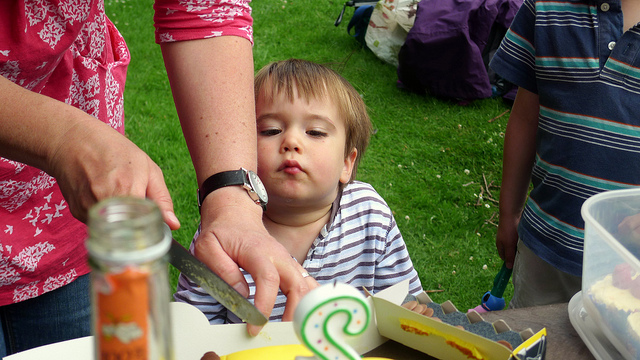What type of event is taking place here? It seems to be a casual outdoor gathering or picnic, characterized by people seated around a table with food items spread out, suggesting a shared meal in a relaxed environment. 